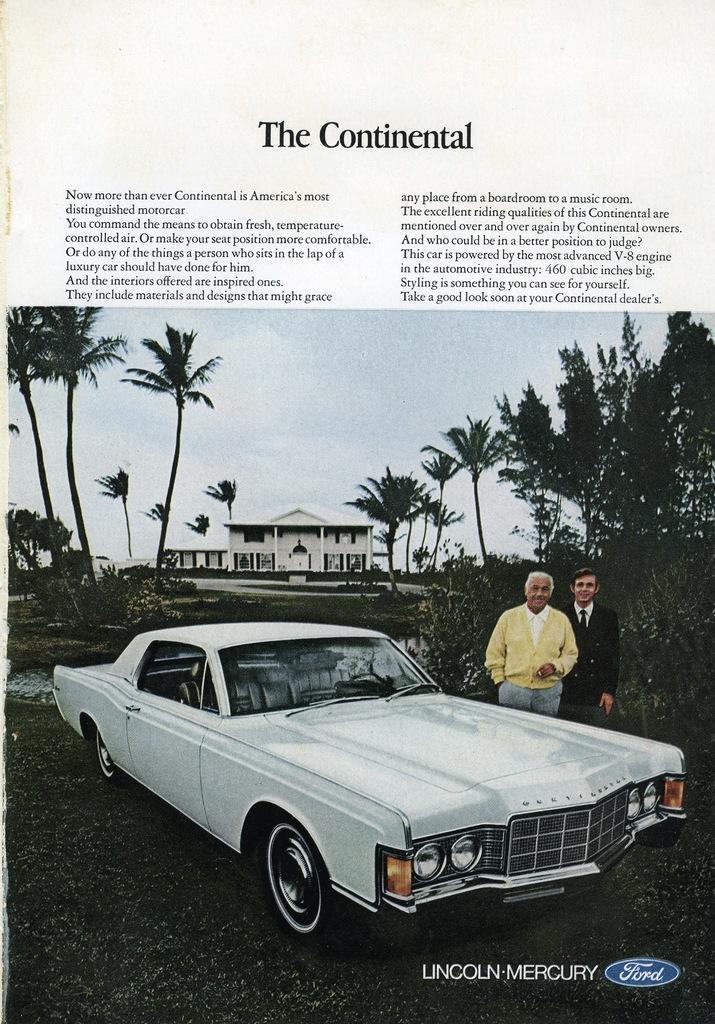Can you describe this image briefly? There is a poster we we can see a car and two men standing beside the car and in the background, there are trees, building and the sky. On the top, there is some text. 